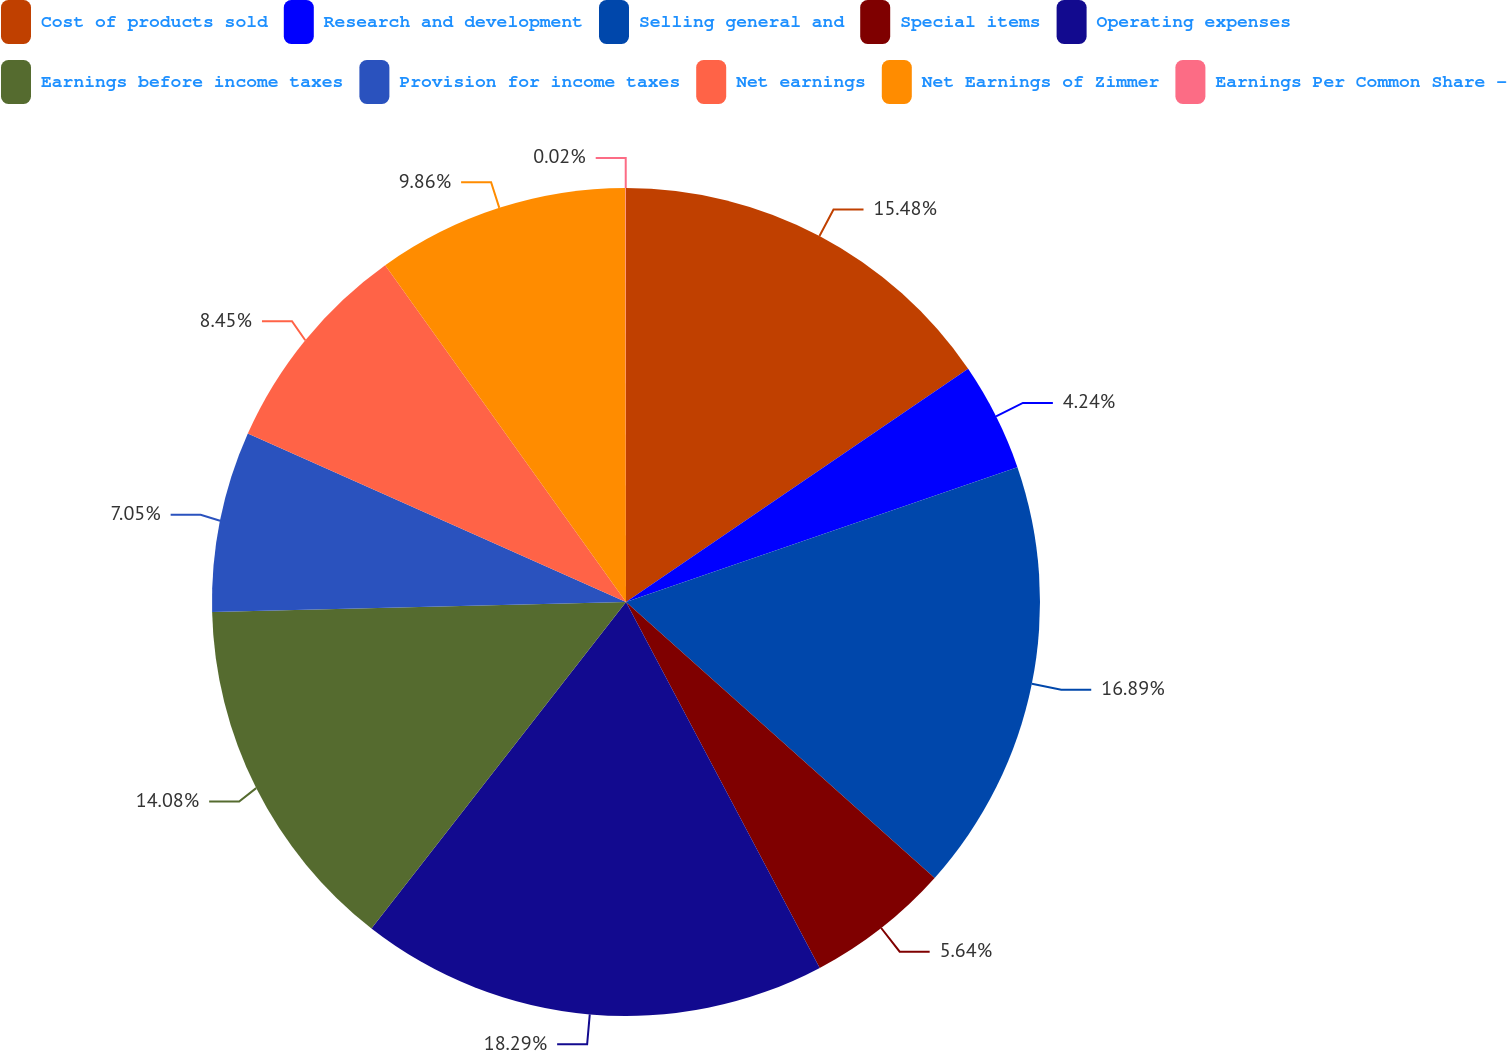<chart> <loc_0><loc_0><loc_500><loc_500><pie_chart><fcel>Cost of products sold<fcel>Research and development<fcel>Selling general and<fcel>Special items<fcel>Operating expenses<fcel>Earnings before income taxes<fcel>Provision for income taxes<fcel>Net earnings<fcel>Net Earnings of Zimmer<fcel>Earnings Per Common Share -<nl><fcel>15.48%<fcel>4.24%<fcel>16.89%<fcel>5.64%<fcel>18.29%<fcel>14.08%<fcel>7.05%<fcel>8.45%<fcel>9.86%<fcel>0.02%<nl></chart> 